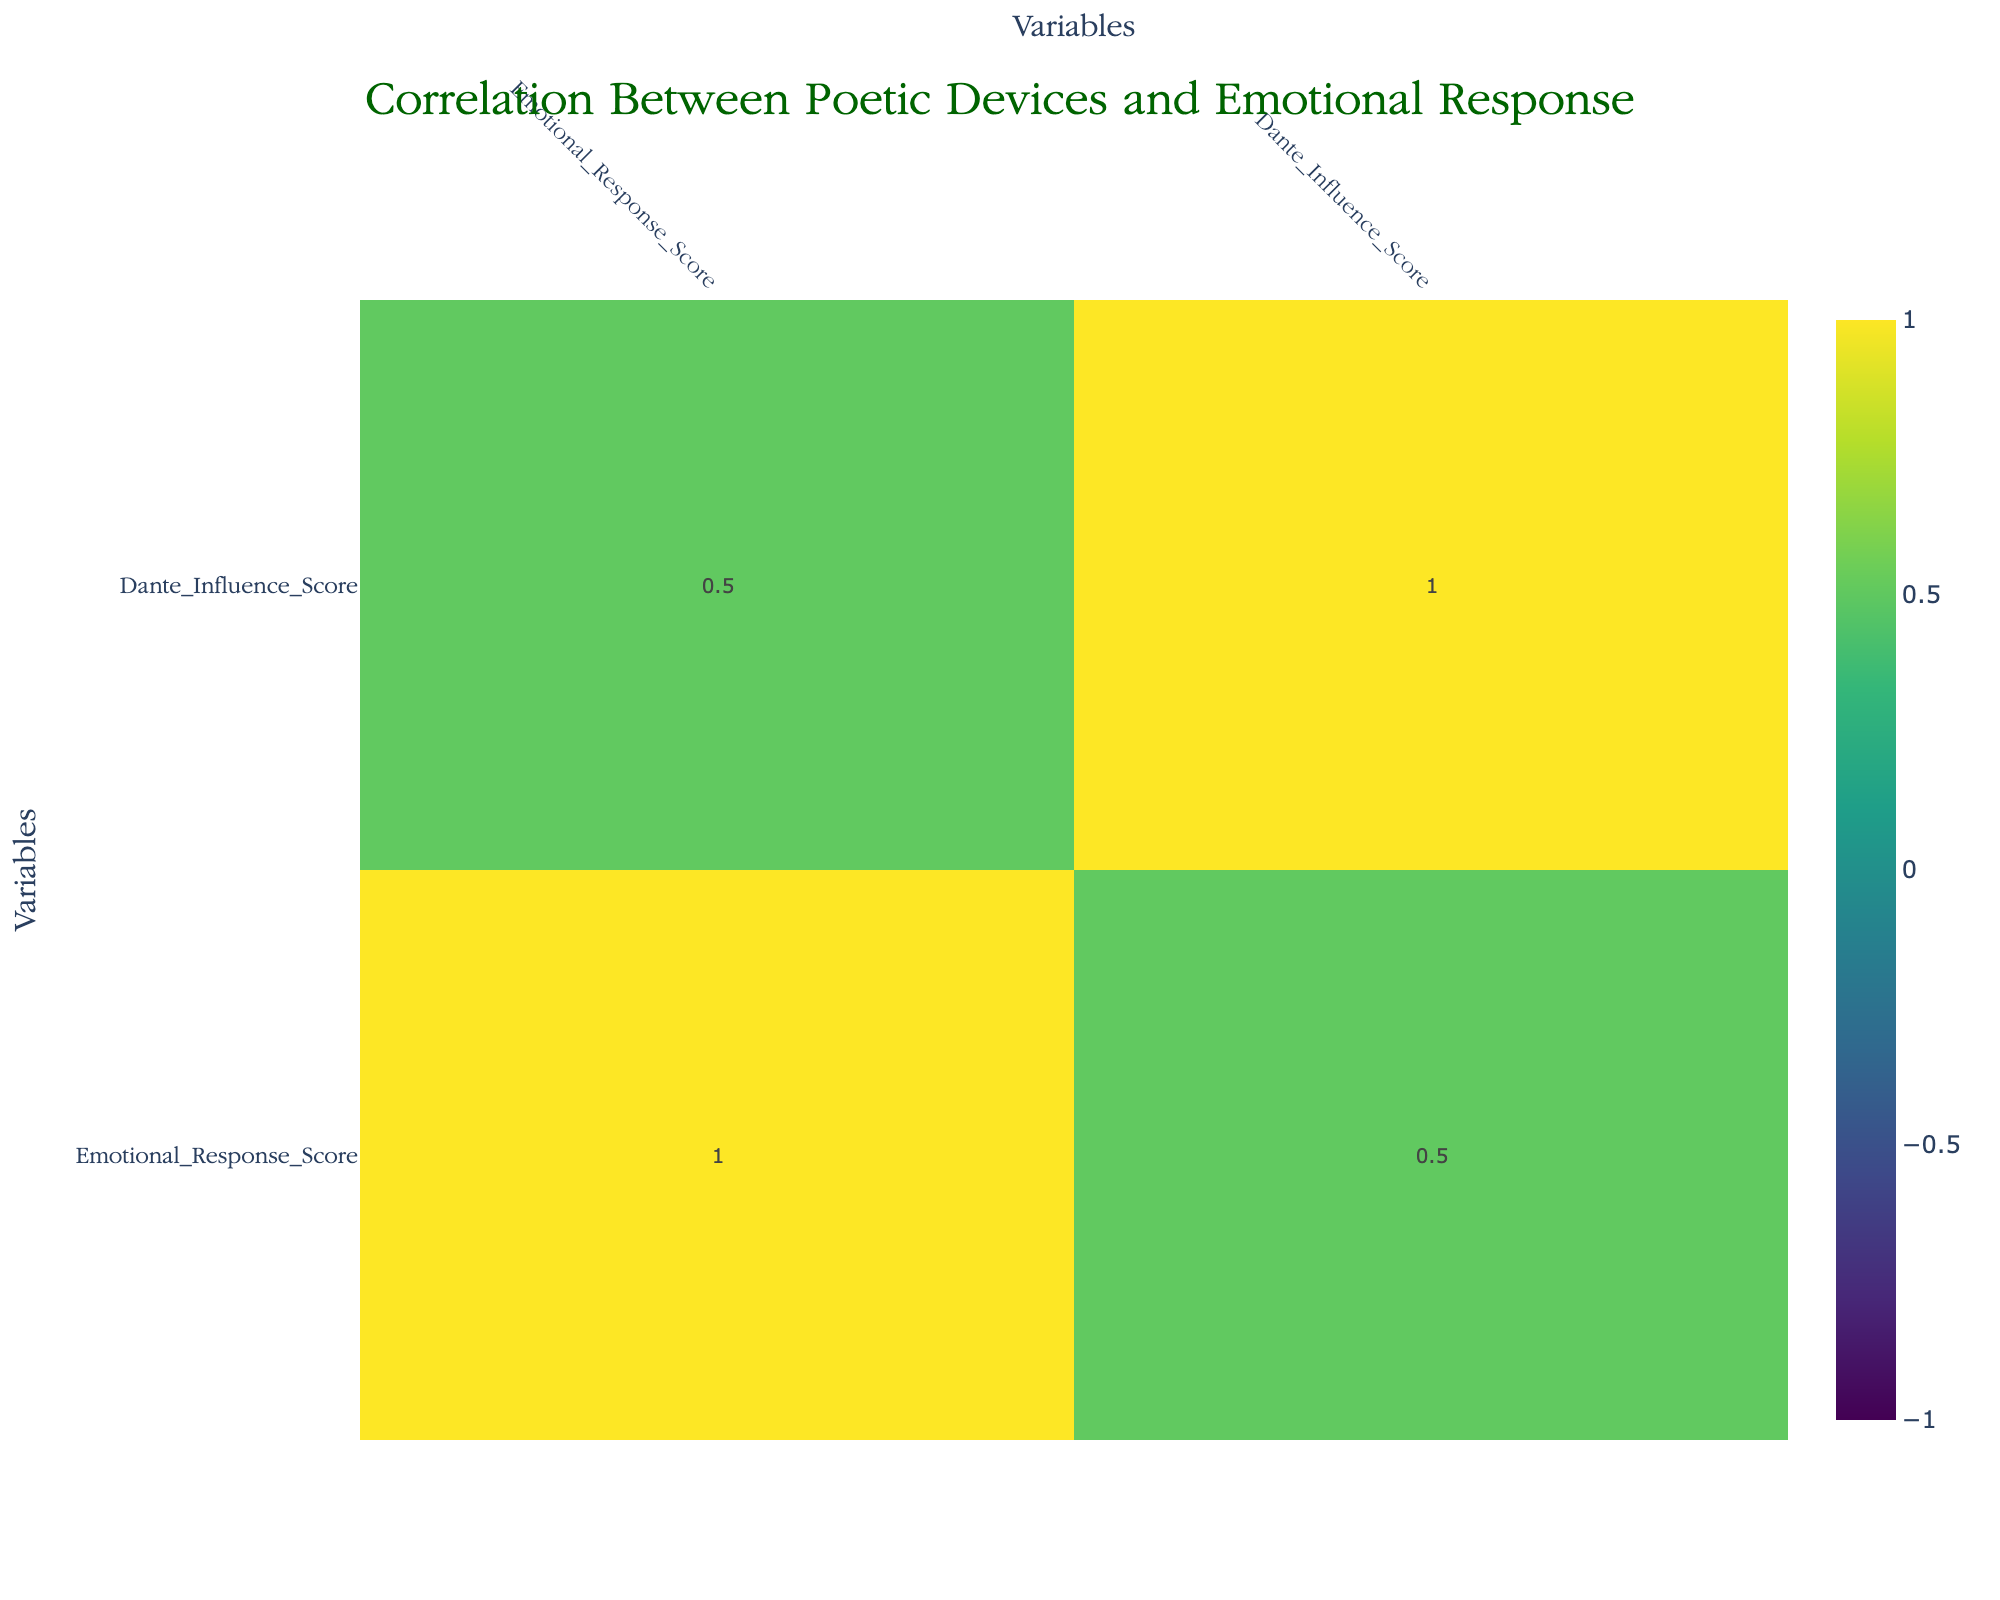What is the Emotional Response Score for Imagery? According to the table, the Emotional Response Score for Imagery is listed directly under the corresponding column, which states it as 9.
Answer: 9 Which poetic device has the highest Dante Influence Score? By comparing the values in the Dante Influence Score column, Imagery and Symbolism both have the highest score of 10, which is the maximum possible score.
Answer: Imagery and Symbolism both have a score of 10 What is the difference between the Emotional Response Score for Alliteration and Repetition? The Emotional Response Score for Alliteration is 7, while for Repetition it is also 7. Therefore, the difference is 7 - 7 = 0.
Answer: 0 Is the Emotional Response Score for Personification greater than that for Oxymoron? The Emotional Response Score for Personification is 8, and for Oxymoron, it is also 8. Since they are equal, the answer is no.
Answer: No What is the average Emotional Response Score of devices with a Dante Influence Score of 9 or higher? The devices with a Dante Influence Score of 9 or higher are Alliteration (7), Metaphor (8), Imagery (9), Symbolism (9), and Iambic Pentameter (8). Their Emotional Response Scores sum up to 7 + 8 + 9 + 9 + 8 = 41, and there are 5 devices, hence the average is 41/5 = 8.2.
Answer: 8.2 Which two poetic devices have an Emotional Response Score of 6? Looking at the Emotional Response Score column, Rhyme and Sibilance both show a score of 6. Therefore, these are the two poetic devices that fit this requirement.
Answer: Rhyme and Sibilance Does alliteration correlate positively with emotional response? In the correlation matrix, a positive correlation indicates that as one score increases, the other does as well. Since Alliteration has an Emotional Response Score of 7, and the correlation with it is positive, the answer is yes.
Answer: Yes What is the emotional response difference between the devices with the highest and lowest scores? The highest Emotional Response Score is 9 (for Imagery and Symbolism) and the lowest is 5 (for Caesura). The difference is 9 - 5 = 4.
Answer: 4 